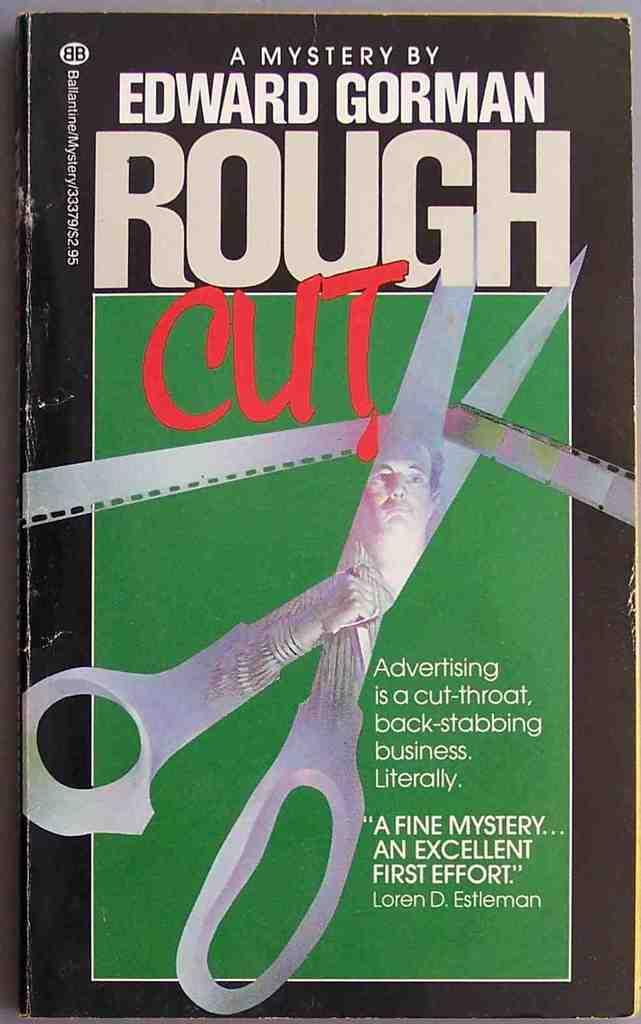<image>
Render a clear and concise summary of the photo. A mystery book by Edward Gorman shows a pair of scissors cutting through a film reel on the cover 